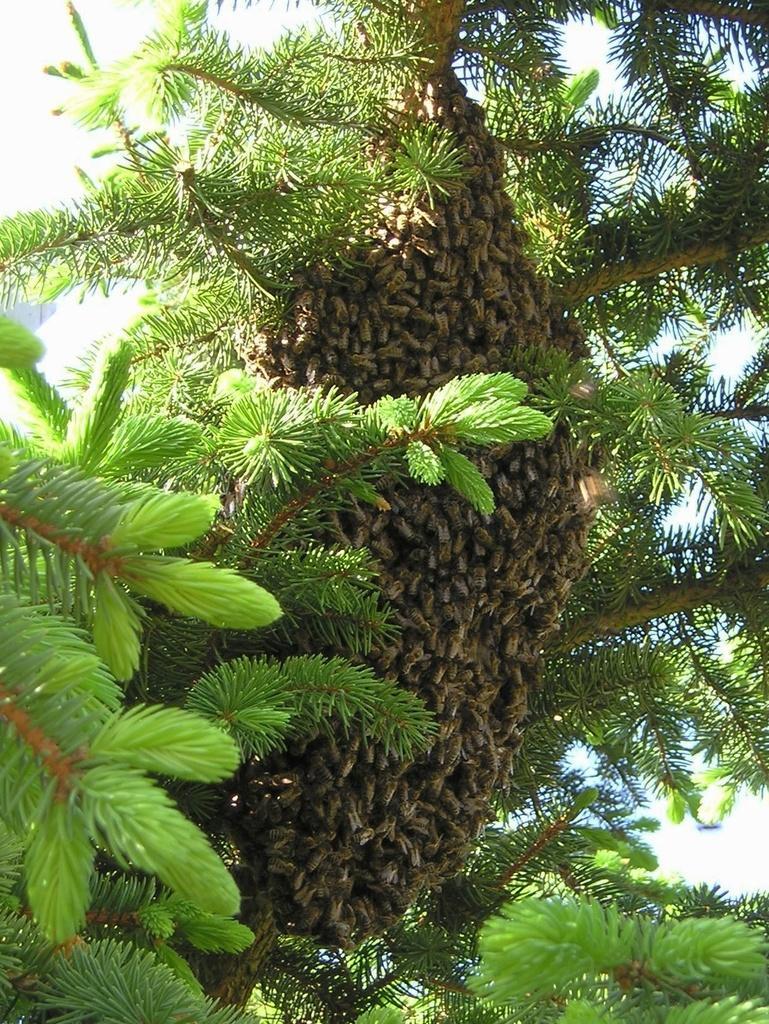Can you describe this image briefly? In the image we can see some trees, on the tree there are some honey bees. Behind the trees there are some clouds and sky. 